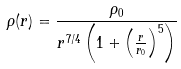<formula> <loc_0><loc_0><loc_500><loc_500>\rho ( r ) = \frac { \rho _ { 0 } } { r ^ { 7 / 4 } \left ( 1 + \left ( \frac { r } { r _ { 0 } } \right ) ^ { 5 } \right ) }</formula> 